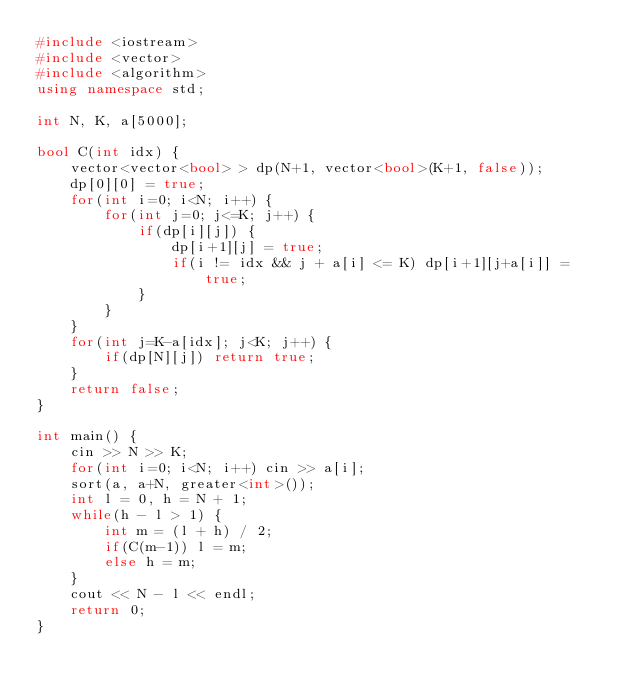<code> <loc_0><loc_0><loc_500><loc_500><_C++_>#include <iostream>
#include <vector>
#include <algorithm>
using namespace std;

int N, K, a[5000];

bool C(int idx) {
    vector<vector<bool> > dp(N+1, vector<bool>(K+1, false));
    dp[0][0] = true;
    for(int i=0; i<N; i++) {
        for(int j=0; j<=K; j++) {
            if(dp[i][j]) {
                dp[i+1][j] = true;
                if(i != idx && j + a[i] <= K) dp[i+1][j+a[i]] = true;
            }
        }
    }
    for(int j=K-a[idx]; j<K; j++) {
        if(dp[N][j]) return true;
    }
    return false;
}

int main() {
    cin >> N >> K;
    for(int i=0; i<N; i++) cin >> a[i];
    sort(a, a+N, greater<int>());
    int l = 0, h = N + 1;
    while(h - l > 1) {
        int m = (l + h) / 2;
        if(C(m-1)) l = m;
        else h = m;
    }
    cout << N - l << endl;
    return 0;
}
</code> 